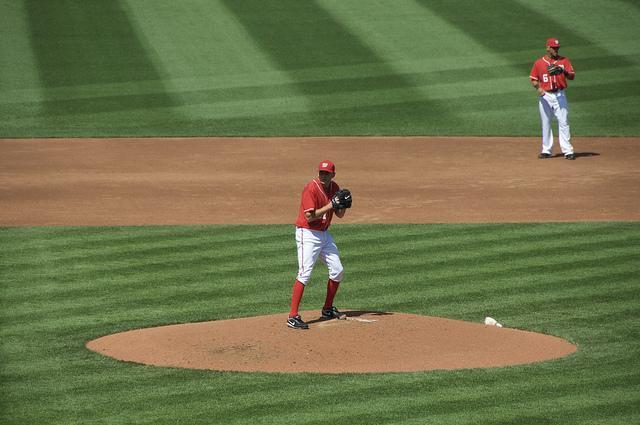How many players on the field?
Give a very brief answer. 2. How many infield players are shown?
Give a very brief answer. 2. How many people are there?
Give a very brief answer. 2. How many animals have a bird on their back?
Give a very brief answer. 0. 